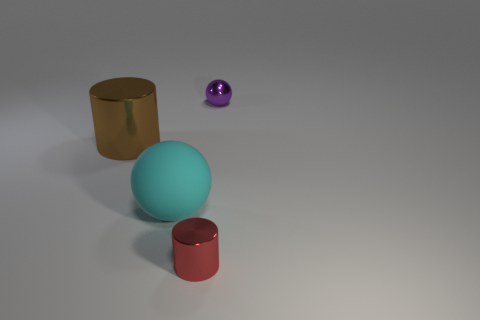Add 1 big yellow matte spheres. How many objects exist? 5 Subtract 1 red cylinders. How many objects are left? 3 Subtract all large cylinders. Subtract all purple metallic things. How many objects are left? 2 Add 2 purple shiny balls. How many purple shiny balls are left? 3 Add 4 green metallic things. How many green metallic things exist? 4 